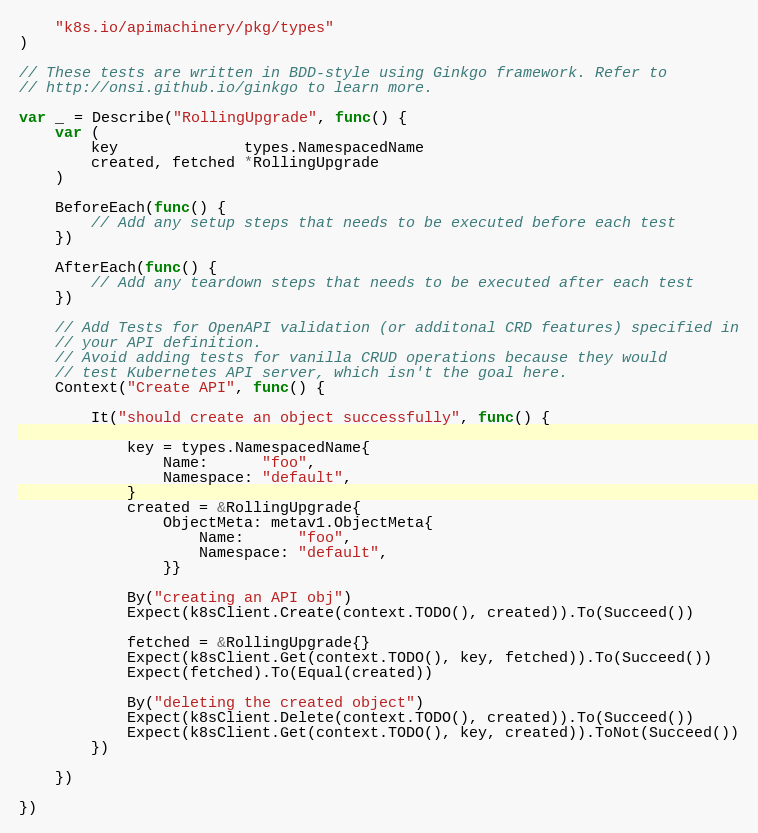<code> <loc_0><loc_0><loc_500><loc_500><_Go_>	"k8s.io/apimachinery/pkg/types"
)

// These tests are written in BDD-style using Ginkgo framework. Refer to
// http://onsi.github.io/ginkgo to learn more.

var _ = Describe("RollingUpgrade", func() {
	var (
		key              types.NamespacedName
		created, fetched *RollingUpgrade
	)

	BeforeEach(func() {
		// Add any setup steps that needs to be executed before each test
	})

	AfterEach(func() {
		// Add any teardown steps that needs to be executed after each test
	})

	// Add Tests for OpenAPI validation (or additonal CRD features) specified in
	// your API definition.
	// Avoid adding tests for vanilla CRUD operations because they would
	// test Kubernetes API server, which isn't the goal here.
	Context("Create API", func() {

		It("should create an object successfully", func() {

			key = types.NamespacedName{
				Name:      "foo",
				Namespace: "default",
			}
			created = &RollingUpgrade{
				ObjectMeta: metav1.ObjectMeta{
					Name:      "foo",
					Namespace: "default",
				}}

			By("creating an API obj")
			Expect(k8sClient.Create(context.TODO(), created)).To(Succeed())

			fetched = &RollingUpgrade{}
			Expect(k8sClient.Get(context.TODO(), key, fetched)).To(Succeed())
			Expect(fetched).To(Equal(created))

			By("deleting the created object")
			Expect(k8sClient.Delete(context.TODO(), created)).To(Succeed())
			Expect(k8sClient.Get(context.TODO(), key, created)).ToNot(Succeed())
		})

	})

})
</code> 